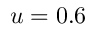Convert formula to latex. <formula><loc_0><loc_0><loc_500><loc_500>u = 0 . 6</formula> 